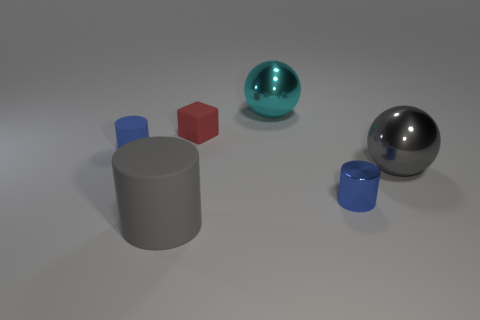What might be the function of these objects in a real-world setting? These objects could serve various purposes; for example, the spheres could be decorative ornaments or part of a game, while the cube and cylinder might be building blocks for children or tools for educational purposes to demonstrate geometry. 